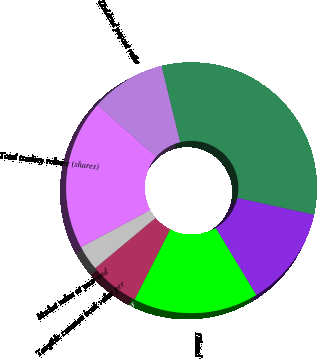Convert chart to OTSL. <chart><loc_0><loc_0><loc_500><loc_500><pie_chart><fcel>Common equity book value per<fcel>Tangible common book value per<fcel>Market value at year-end<fcel>Total trading volume (shares)<fcel>Dividend payout ratio<fcel>Stockholders of record at<fcel>Basic<fcel>Diluted<nl><fcel>6.45%<fcel>0.01%<fcel>3.23%<fcel>19.35%<fcel>9.68%<fcel>32.25%<fcel>12.9%<fcel>16.13%<nl></chart> 